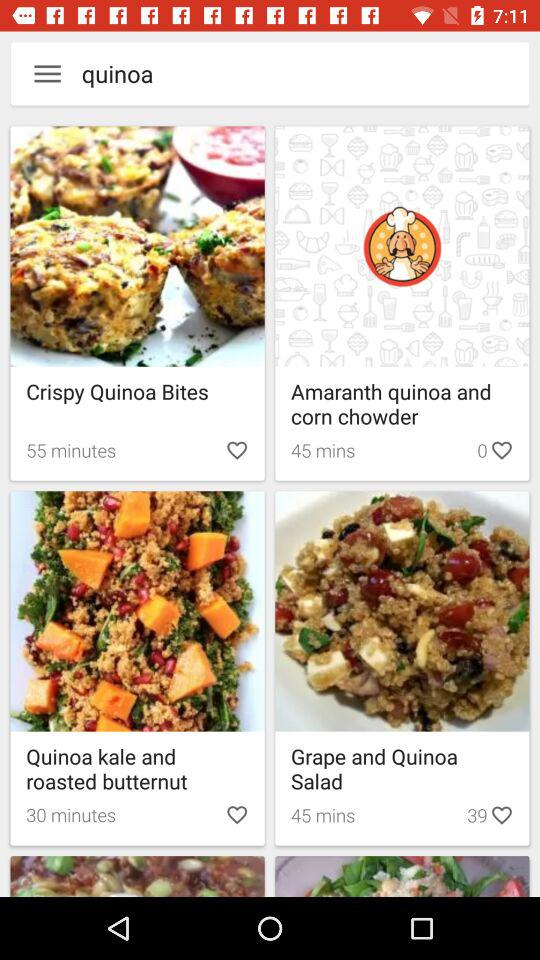How many likes are there for "Amaranth quinoa and corn chowder"? There are 0 likes. 